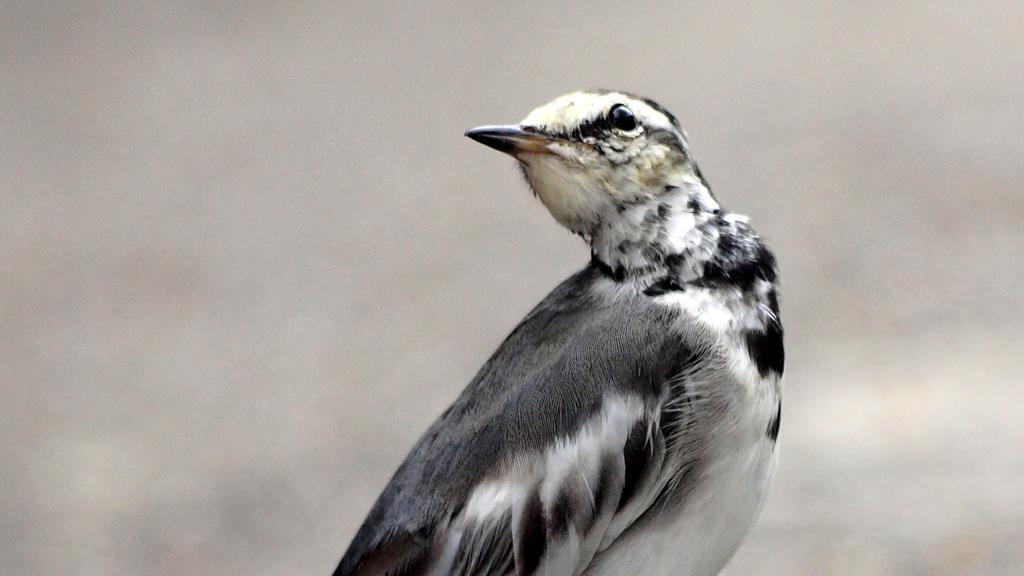In one or two sentences, can you explain what this image depicts? In this image we can see one bird. 